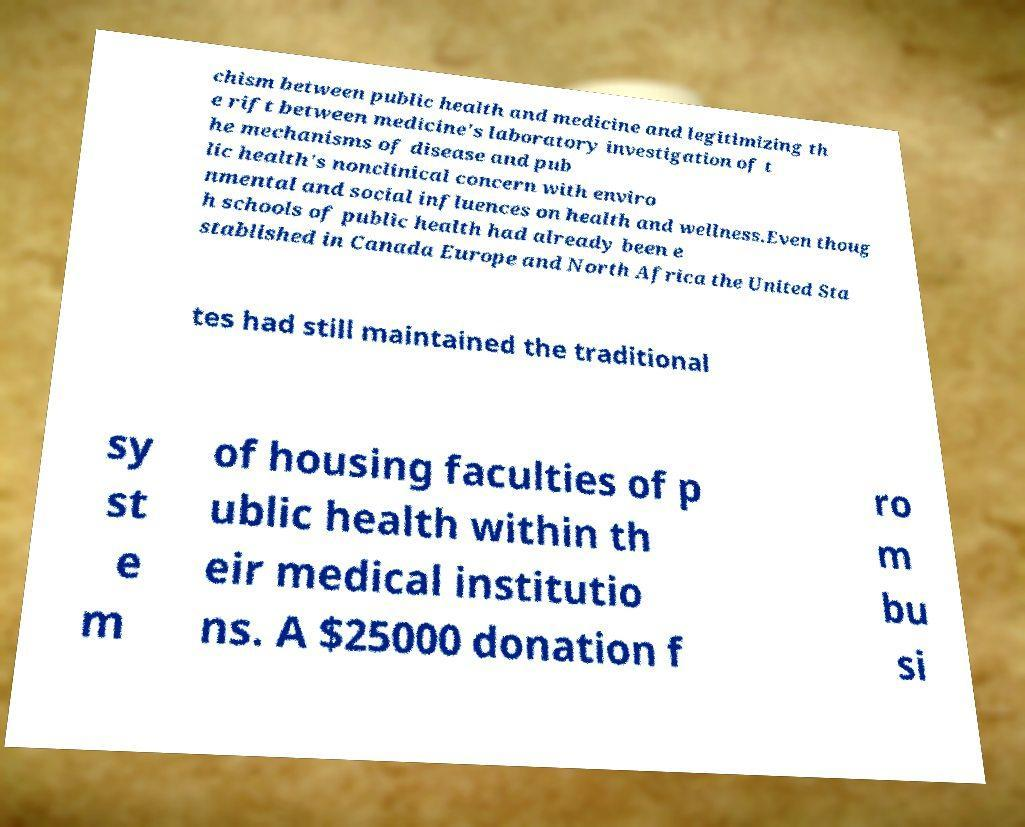Please identify and transcribe the text found in this image. chism between public health and medicine and legitimizing th e rift between medicine's laboratory investigation of t he mechanisms of disease and pub lic health's nonclinical concern with enviro nmental and social influences on health and wellness.Even thoug h schools of public health had already been e stablished in Canada Europe and North Africa the United Sta tes had still maintained the traditional sy st e m of housing faculties of p ublic health within th eir medical institutio ns. A $25000 donation f ro m bu si 